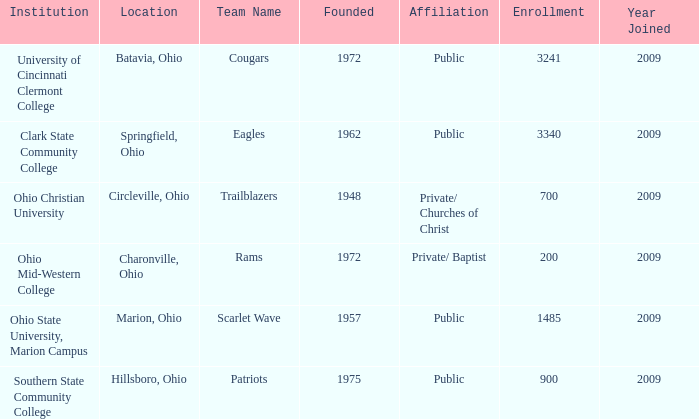What was the location for the team name of patriots? Hillsboro, Ohio. 